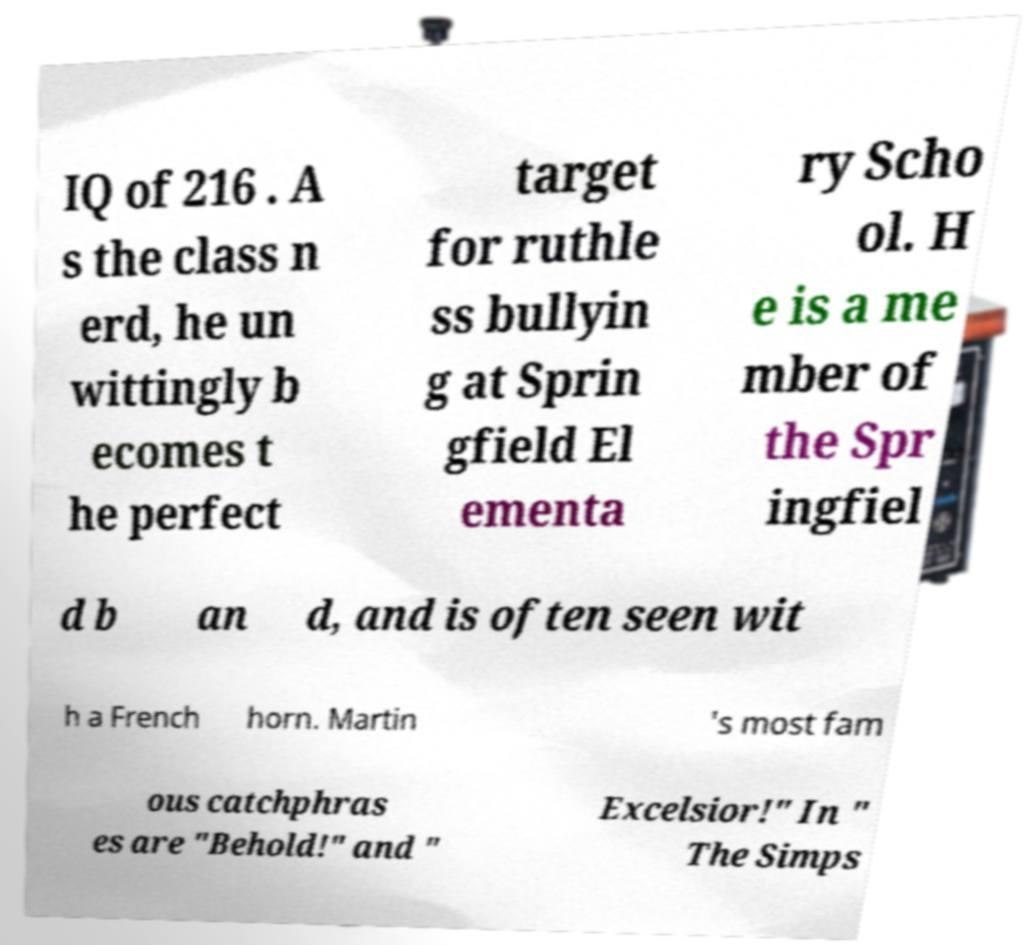For documentation purposes, I need the text within this image transcribed. Could you provide that? IQ of 216 . A s the class n erd, he un wittingly b ecomes t he perfect target for ruthle ss bullyin g at Sprin gfield El ementa ry Scho ol. H e is a me mber of the Spr ingfiel d b an d, and is often seen wit h a French horn. Martin 's most fam ous catchphras es are "Behold!" and " Excelsior!" In " The Simps 